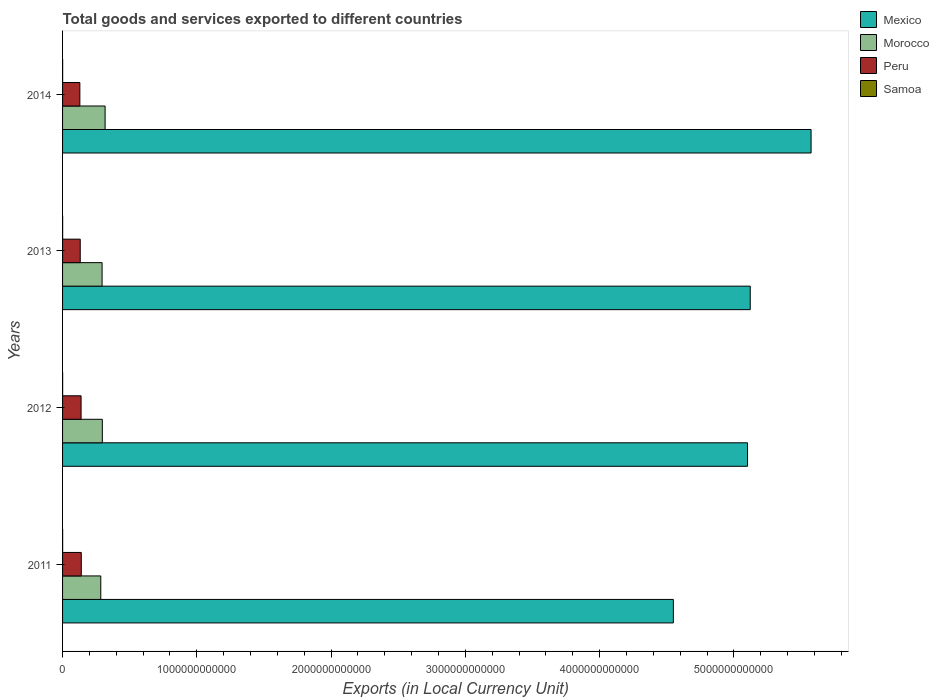How many groups of bars are there?
Give a very brief answer. 4. Are the number of bars per tick equal to the number of legend labels?
Provide a short and direct response. Yes. How many bars are there on the 4th tick from the bottom?
Provide a short and direct response. 4. In how many cases, is the number of bars for a given year not equal to the number of legend labels?
Keep it short and to the point. 0. What is the Amount of goods and services exports in Morocco in 2013?
Give a very brief answer. 2.94e+11. Across all years, what is the maximum Amount of goods and services exports in Peru?
Make the answer very short. 1.39e+11. Across all years, what is the minimum Amount of goods and services exports in Mexico?
Your answer should be compact. 4.55e+12. What is the total Amount of goods and services exports in Morocco in the graph?
Keep it short and to the point. 1.19e+12. What is the difference between the Amount of goods and services exports in Morocco in 2012 and that in 2013?
Provide a succinct answer. 1.84e+09. What is the difference between the Amount of goods and services exports in Mexico in 2011 and the Amount of goods and services exports in Peru in 2014?
Make the answer very short. 4.42e+12. What is the average Amount of goods and services exports in Peru per year?
Provide a succinct answer. 1.34e+11. In the year 2013, what is the difference between the Amount of goods and services exports in Peru and Amount of goods and services exports in Mexico?
Offer a very short reply. -4.99e+12. What is the ratio of the Amount of goods and services exports in Mexico in 2011 to that in 2014?
Provide a short and direct response. 0.82. What is the difference between the highest and the second highest Amount of goods and services exports in Samoa?
Your answer should be very brief. 3.05e+07. What is the difference between the highest and the lowest Amount of goods and services exports in Morocco?
Your answer should be very brief. 3.23e+1. In how many years, is the Amount of goods and services exports in Samoa greater than the average Amount of goods and services exports in Samoa taken over all years?
Make the answer very short. 2. Is the sum of the Amount of goods and services exports in Samoa in 2011 and 2014 greater than the maximum Amount of goods and services exports in Peru across all years?
Make the answer very short. No. What does the 3rd bar from the top in 2014 represents?
Make the answer very short. Morocco. What does the 3rd bar from the bottom in 2011 represents?
Provide a succinct answer. Peru. Are all the bars in the graph horizontal?
Provide a short and direct response. Yes. How many years are there in the graph?
Provide a short and direct response. 4. What is the difference between two consecutive major ticks on the X-axis?
Make the answer very short. 1.00e+12. Are the values on the major ticks of X-axis written in scientific E-notation?
Your answer should be compact. No. Where does the legend appear in the graph?
Offer a terse response. Top right. What is the title of the graph?
Offer a very short reply. Total goods and services exported to different countries. Does "South Sudan" appear as one of the legend labels in the graph?
Offer a very short reply. No. What is the label or title of the X-axis?
Provide a succinct answer. Exports (in Local Currency Unit). What is the Exports (in Local Currency Unit) in Mexico in 2011?
Offer a terse response. 4.55e+12. What is the Exports (in Local Currency Unit) of Morocco in 2011?
Make the answer very short. 2.85e+11. What is the Exports (in Local Currency Unit) of Peru in 2011?
Provide a short and direct response. 1.39e+11. What is the Exports (in Local Currency Unit) of Samoa in 2011?
Give a very brief answer. 5.07e+08. What is the Exports (in Local Currency Unit) of Mexico in 2012?
Provide a succinct answer. 5.10e+12. What is the Exports (in Local Currency Unit) in Morocco in 2012?
Make the answer very short. 2.96e+11. What is the Exports (in Local Currency Unit) of Peru in 2012?
Your answer should be compact. 1.38e+11. What is the Exports (in Local Currency Unit) of Samoa in 2012?
Give a very brief answer. 5.10e+08. What is the Exports (in Local Currency Unit) in Mexico in 2013?
Your answer should be compact. 5.12e+12. What is the Exports (in Local Currency Unit) in Morocco in 2013?
Keep it short and to the point. 2.94e+11. What is the Exports (in Local Currency Unit) of Peru in 2013?
Provide a succinct answer. 1.32e+11. What is the Exports (in Local Currency Unit) of Samoa in 2013?
Make the answer very short. 5.58e+08. What is the Exports (in Local Currency Unit) of Mexico in 2014?
Give a very brief answer. 5.57e+12. What is the Exports (in Local Currency Unit) in Morocco in 2014?
Your answer should be very brief. 3.17e+11. What is the Exports (in Local Currency Unit) of Peru in 2014?
Make the answer very short. 1.29e+11. What is the Exports (in Local Currency Unit) of Samoa in 2014?
Provide a succinct answer. 5.27e+08. Across all years, what is the maximum Exports (in Local Currency Unit) in Mexico?
Your answer should be compact. 5.57e+12. Across all years, what is the maximum Exports (in Local Currency Unit) of Morocco?
Your response must be concise. 3.17e+11. Across all years, what is the maximum Exports (in Local Currency Unit) in Peru?
Your answer should be compact. 1.39e+11. Across all years, what is the maximum Exports (in Local Currency Unit) of Samoa?
Your response must be concise. 5.58e+08. Across all years, what is the minimum Exports (in Local Currency Unit) in Mexico?
Keep it short and to the point. 4.55e+12. Across all years, what is the minimum Exports (in Local Currency Unit) of Morocco?
Give a very brief answer. 2.85e+11. Across all years, what is the minimum Exports (in Local Currency Unit) of Peru?
Your answer should be very brief. 1.29e+11. Across all years, what is the minimum Exports (in Local Currency Unit) of Samoa?
Give a very brief answer. 5.07e+08. What is the total Exports (in Local Currency Unit) in Mexico in the graph?
Your answer should be compact. 2.03e+13. What is the total Exports (in Local Currency Unit) of Morocco in the graph?
Your answer should be compact. 1.19e+12. What is the total Exports (in Local Currency Unit) of Peru in the graph?
Provide a succinct answer. 5.38e+11. What is the total Exports (in Local Currency Unit) of Samoa in the graph?
Give a very brief answer. 2.10e+09. What is the difference between the Exports (in Local Currency Unit) of Mexico in 2011 and that in 2012?
Your answer should be very brief. -5.52e+11. What is the difference between the Exports (in Local Currency Unit) of Morocco in 2011 and that in 2012?
Make the answer very short. -1.16e+1. What is the difference between the Exports (in Local Currency Unit) in Peru in 2011 and that in 2012?
Give a very brief answer. 1.42e+09. What is the difference between the Exports (in Local Currency Unit) of Samoa in 2011 and that in 2012?
Offer a terse response. -3.29e+06. What is the difference between the Exports (in Local Currency Unit) in Mexico in 2011 and that in 2013?
Offer a very short reply. -5.73e+11. What is the difference between the Exports (in Local Currency Unit) of Morocco in 2011 and that in 2013?
Offer a terse response. -9.75e+09. What is the difference between the Exports (in Local Currency Unit) in Peru in 2011 and that in 2013?
Your response must be concise. 7.71e+09. What is the difference between the Exports (in Local Currency Unit) of Samoa in 2011 and that in 2013?
Your answer should be very brief. -5.06e+07. What is the difference between the Exports (in Local Currency Unit) of Mexico in 2011 and that in 2014?
Offer a very short reply. -1.03e+12. What is the difference between the Exports (in Local Currency Unit) of Morocco in 2011 and that in 2014?
Your answer should be compact. -3.23e+1. What is the difference between the Exports (in Local Currency Unit) in Peru in 2011 and that in 2014?
Ensure brevity in your answer.  1.05e+1. What is the difference between the Exports (in Local Currency Unit) of Samoa in 2011 and that in 2014?
Keep it short and to the point. -2.02e+07. What is the difference between the Exports (in Local Currency Unit) in Mexico in 2012 and that in 2013?
Offer a very short reply. -2.02e+1. What is the difference between the Exports (in Local Currency Unit) in Morocco in 2012 and that in 2013?
Make the answer very short. 1.84e+09. What is the difference between the Exports (in Local Currency Unit) of Peru in 2012 and that in 2013?
Ensure brevity in your answer.  6.30e+09. What is the difference between the Exports (in Local Currency Unit) in Samoa in 2012 and that in 2013?
Make the answer very short. -4.74e+07. What is the difference between the Exports (in Local Currency Unit) of Mexico in 2012 and that in 2014?
Your answer should be very brief. -4.73e+11. What is the difference between the Exports (in Local Currency Unit) of Morocco in 2012 and that in 2014?
Offer a very short reply. -2.07e+1. What is the difference between the Exports (in Local Currency Unit) of Peru in 2012 and that in 2014?
Your answer should be compact. 9.07e+09. What is the difference between the Exports (in Local Currency Unit) of Samoa in 2012 and that in 2014?
Your answer should be compact. -1.69e+07. What is the difference between the Exports (in Local Currency Unit) of Mexico in 2013 and that in 2014?
Ensure brevity in your answer.  -4.53e+11. What is the difference between the Exports (in Local Currency Unit) of Morocco in 2013 and that in 2014?
Provide a succinct answer. -2.25e+1. What is the difference between the Exports (in Local Currency Unit) in Peru in 2013 and that in 2014?
Ensure brevity in your answer.  2.78e+09. What is the difference between the Exports (in Local Currency Unit) of Samoa in 2013 and that in 2014?
Keep it short and to the point. 3.05e+07. What is the difference between the Exports (in Local Currency Unit) in Mexico in 2011 and the Exports (in Local Currency Unit) in Morocco in 2012?
Provide a short and direct response. 4.25e+12. What is the difference between the Exports (in Local Currency Unit) in Mexico in 2011 and the Exports (in Local Currency Unit) in Peru in 2012?
Offer a terse response. 4.41e+12. What is the difference between the Exports (in Local Currency Unit) in Mexico in 2011 and the Exports (in Local Currency Unit) in Samoa in 2012?
Your response must be concise. 4.55e+12. What is the difference between the Exports (in Local Currency Unit) of Morocco in 2011 and the Exports (in Local Currency Unit) of Peru in 2012?
Ensure brevity in your answer.  1.47e+11. What is the difference between the Exports (in Local Currency Unit) of Morocco in 2011 and the Exports (in Local Currency Unit) of Samoa in 2012?
Keep it short and to the point. 2.84e+11. What is the difference between the Exports (in Local Currency Unit) of Peru in 2011 and the Exports (in Local Currency Unit) of Samoa in 2012?
Keep it short and to the point. 1.39e+11. What is the difference between the Exports (in Local Currency Unit) in Mexico in 2011 and the Exports (in Local Currency Unit) in Morocco in 2013?
Your answer should be very brief. 4.25e+12. What is the difference between the Exports (in Local Currency Unit) in Mexico in 2011 and the Exports (in Local Currency Unit) in Peru in 2013?
Provide a short and direct response. 4.42e+12. What is the difference between the Exports (in Local Currency Unit) of Mexico in 2011 and the Exports (in Local Currency Unit) of Samoa in 2013?
Keep it short and to the point. 4.55e+12. What is the difference between the Exports (in Local Currency Unit) of Morocco in 2011 and the Exports (in Local Currency Unit) of Peru in 2013?
Your answer should be compact. 1.53e+11. What is the difference between the Exports (in Local Currency Unit) in Morocco in 2011 and the Exports (in Local Currency Unit) in Samoa in 2013?
Offer a terse response. 2.84e+11. What is the difference between the Exports (in Local Currency Unit) of Peru in 2011 and the Exports (in Local Currency Unit) of Samoa in 2013?
Your response must be concise. 1.39e+11. What is the difference between the Exports (in Local Currency Unit) in Mexico in 2011 and the Exports (in Local Currency Unit) in Morocco in 2014?
Offer a very short reply. 4.23e+12. What is the difference between the Exports (in Local Currency Unit) in Mexico in 2011 and the Exports (in Local Currency Unit) in Peru in 2014?
Your answer should be compact. 4.42e+12. What is the difference between the Exports (in Local Currency Unit) of Mexico in 2011 and the Exports (in Local Currency Unit) of Samoa in 2014?
Your answer should be compact. 4.55e+12. What is the difference between the Exports (in Local Currency Unit) of Morocco in 2011 and the Exports (in Local Currency Unit) of Peru in 2014?
Offer a terse response. 1.56e+11. What is the difference between the Exports (in Local Currency Unit) in Morocco in 2011 and the Exports (in Local Currency Unit) in Samoa in 2014?
Offer a very short reply. 2.84e+11. What is the difference between the Exports (in Local Currency Unit) of Peru in 2011 and the Exports (in Local Currency Unit) of Samoa in 2014?
Your answer should be compact. 1.39e+11. What is the difference between the Exports (in Local Currency Unit) of Mexico in 2012 and the Exports (in Local Currency Unit) of Morocco in 2013?
Give a very brief answer. 4.81e+12. What is the difference between the Exports (in Local Currency Unit) of Mexico in 2012 and the Exports (in Local Currency Unit) of Peru in 2013?
Offer a terse response. 4.97e+12. What is the difference between the Exports (in Local Currency Unit) of Mexico in 2012 and the Exports (in Local Currency Unit) of Samoa in 2013?
Give a very brief answer. 5.10e+12. What is the difference between the Exports (in Local Currency Unit) in Morocco in 2012 and the Exports (in Local Currency Unit) in Peru in 2013?
Keep it short and to the point. 1.65e+11. What is the difference between the Exports (in Local Currency Unit) of Morocco in 2012 and the Exports (in Local Currency Unit) of Samoa in 2013?
Your answer should be compact. 2.96e+11. What is the difference between the Exports (in Local Currency Unit) in Peru in 2012 and the Exports (in Local Currency Unit) in Samoa in 2013?
Your answer should be very brief. 1.37e+11. What is the difference between the Exports (in Local Currency Unit) of Mexico in 2012 and the Exports (in Local Currency Unit) of Morocco in 2014?
Keep it short and to the point. 4.78e+12. What is the difference between the Exports (in Local Currency Unit) in Mexico in 2012 and the Exports (in Local Currency Unit) in Peru in 2014?
Ensure brevity in your answer.  4.97e+12. What is the difference between the Exports (in Local Currency Unit) of Mexico in 2012 and the Exports (in Local Currency Unit) of Samoa in 2014?
Keep it short and to the point. 5.10e+12. What is the difference between the Exports (in Local Currency Unit) in Morocco in 2012 and the Exports (in Local Currency Unit) in Peru in 2014?
Your response must be concise. 1.67e+11. What is the difference between the Exports (in Local Currency Unit) in Morocco in 2012 and the Exports (in Local Currency Unit) in Samoa in 2014?
Make the answer very short. 2.96e+11. What is the difference between the Exports (in Local Currency Unit) of Peru in 2012 and the Exports (in Local Currency Unit) of Samoa in 2014?
Your answer should be very brief. 1.37e+11. What is the difference between the Exports (in Local Currency Unit) of Mexico in 2013 and the Exports (in Local Currency Unit) of Morocco in 2014?
Make the answer very short. 4.80e+12. What is the difference between the Exports (in Local Currency Unit) of Mexico in 2013 and the Exports (in Local Currency Unit) of Peru in 2014?
Give a very brief answer. 4.99e+12. What is the difference between the Exports (in Local Currency Unit) of Mexico in 2013 and the Exports (in Local Currency Unit) of Samoa in 2014?
Provide a short and direct response. 5.12e+12. What is the difference between the Exports (in Local Currency Unit) of Morocco in 2013 and the Exports (in Local Currency Unit) of Peru in 2014?
Offer a terse response. 1.65e+11. What is the difference between the Exports (in Local Currency Unit) in Morocco in 2013 and the Exports (in Local Currency Unit) in Samoa in 2014?
Make the answer very short. 2.94e+11. What is the difference between the Exports (in Local Currency Unit) in Peru in 2013 and the Exports (in Local Currency Unit) in Samoa in 2014?
Keep it short and to the point. 1.31e+11. What is the average Exports (in Local Currency Unit) in Mexico per year?
Your answer should be compact. 5.09e+12. What is the average Exports (in Local Currency Unit) in Morocco per year?
Provide a short and direct response. 2.98e+11. What is the average Exports (in Local Currency Unit) of Peru per year?
Provide a succinct answer. 1.34e+11. What is the average Exports (in Local Currency Unit) of Samoa per year?
Your response must be concise. 5.25e+08. In the year 2011, what is the difference between the Exports (in Local Currency Unit) in Mexico and Exports (in Local Currency Unit) in Morocco?
Your response must be concise. 4.26e+12. In the year 2011, what is the difference between the Exports (in Local Currency Unit) of Mexico and Exports (in Local Currency Unit) of Peru?
Give a very brief answer. 4.41e+12. In the year 2011, what is the difference between the Exports (in Local Currency Unit) in Mexico and Exports (in Local Currency Unit) in Samoa?
Offer a terse response. 4.55e+12. In the year 2011, what is the difference between the Exports (in Local Currency Unit) of Morocco and Exports (in Local Currency Unit) of Peru?
Your answer should be very brief. 1.45e+11. In the year 2011, what is the difference between the Exports (in Local Currency Unit) of Morocco and Exports (in Local Currency Unit) of Samoa?
Give a very brief answer. 2.84e+11. In the year 2011, what is the difference between the Exports (in Local Currency Unit) of Peru and Exports (in Local Currency Unit) of Samoa?
Offer a terse response. 1.39e+11. In the year 2012, what is the difference between the Exports (in Local Currency Unit) of Mexico and Exports (in Local Currency Unit) of Morocco?
Your response must be concise. 4.81e+12. In the year 2012, what is the difference between the Exports (in Local Currency Unit) of Mexico and Exports (in Local Currency Unit) of Peru?
Provide a short and direct response. 4.96e+12. In the year 2012, what is the difference between the Exports (in Local Currency Unit) of Mexico and Exports (in Local Currency Unit) of Samoa?
Provide a succinct answer. 5.10e+12. In the year 2012, what is the difference between the Exports (in Local Currency Unit) of Morocco and Exports (in Local Currency Unit) of Peru?
Keep it short and to the point. 1.58e+11. In the year 2012, what is the difference between the Exports (in Local Currency Unit) of Morocco and Exports (in Local Currency Unit) of Samoa?
Keep it short and to the point. 2.96e+11. In the year 2012, what is the difference between the Exports (in Local Currency Unit) of Peru and Exports (in Local Currency Unit) of Samoa?
Give a very brief answer. 1.37e+11. In the year 2013, what is the difference between the Exports (in Local Currency Unit) in Mexico and Exports (in Local Currency Unit) in Morocco?
Make the answer very short. 4.83e+12. In the year 2013, what is the difference between the Exports (in Local Currency Unit) of Mexico and Exports (in Local Currency Unit) of Peru?
Give a very brief answer. 4.99e+12. In the year 2013, what is the difference between the Exports (in Local Currency Unit) of Mexico and Exports (in Local Currency Unit) of Samoa?
Provide a short and direct response. 5.12e+12. In the year 2013, what is the difference between the Exports (in Local Currency Unit) of Morocco and Exports (in Local Currency Unit) of Peru?
Offer a very short reply. 1.63e+11. In the year 2013, what is the difference between the Exports (in Local Currency Unit) in Morocco and Exports (in Local Currency Unit) in Samoa?
Provide a short and direct response. 2.94e+11. In the year 2013, what is the difference between the Exports (in Local Currency Unit) in Peru and Exports (in Local Currency Unit) in Samoa?
Your answer should be compact. 1.31e+11. In the year 2014, what is the difference between the Exports (in Local Currency Unit) in Mexico and Exports (in Local Currency Unit) in Morocco?
Make the answer very short. 5.26e+12. In the year 2014, what is the difference between the Exports (in Local Currency Unit) in Mexico and Exports (in Local Currency Unit) in Peru?
Offer a terse response. 5.45e+12. In the year 2014, what is the difference between the Exports (in Local Currency Unit) of Mexico and Exports (in Local Currency Unit) of Samoa?
Offer a very short reply. 5.57e+12. In the year 2014, what is the difference between the Exports (in Local Currency Unit) of Morocco and Exports (in Local Currency Unit) of Peru?
Offer a very short reply. 1.88e+11. In the year 2014, what is the difference between the Exports (in Local Currency Unit) in Morocco and Exports (in Local Currency Unit) in Samoa?
Make the answer very short. 3.16e+11. In the year 2014, what is the difference between the Exports (in Local Currency Unit) in Peru and Exports (in Local Currency Unit) in Samoa?
Offer a terse response. 1.28e+11. What is the ratio of the Exports (in Local Currency Unit) in Mexico in 2011 to that in 2012?
Offer a terse response. 0.89. What is the ratio of the Exports (in Local Currency Unit) of Morocco in 2011 to that in 2012?
Your answer should be compact. 0.96. What is the ratio of the Exports (in Local Currency Unit) of Peru in 2011 to that in 2012?
Make the answer very short. 1.01. What is the ratio of the Exports (in Local Currency Unit) of Samoa in 2011 to that in 2012?
Keep it short and to the point. 0.99. What is the ratio of the Exports (in Local Currency Unit) of Mexico in 2011 to that in 2013?
Offer a very short reply. 0.89. What is the ratio of the Exports (in Local Currency Unit) in Morocco in 2011 to that in 2013?
Keep it short and to the point. 0.97. What is the ratio of the Exports (in Local Currency Unit) in Peru in 2011 to that in 2013?
Your answer should be compact. 1.06. What is the ratio of the Exports (in Local Currency Unit) of Samoa in 2011 to that in 2013?
Your answer should be very brief. 0.91. What is the ratio of the Exports (in Local Currency Unit) in Mexico in 2011 to that in 2014?
Ensure brevity in your answer.  0.82. What is the ratio of the Exports (in Local Currency Unit) of Morocco in 2011 to that in 2014?
Your answer should be compact. 0.9. What is the ratio of the Exports (in Local Currency Unit) in Peru in 2011 to that in 2014?
Offer a terse response. 1.08. What is the ratio of the Exports (in Local Currency Unit) of Samoa in 2011 to that in 2014?
Your answer should be compact. 0.96. What is the ratio of the Exports (in Local Currency Unit) of Morocco in 2012 to that in 2013?
Keep it short and to the point. 1.01. What is the ratio of the Exports (in Local Currency Unit) in Peru in 2012 to that in 2013?
Keep it short and to the point. 1.05. What is the ratio of the Exports (in Local Currency Unit) in Samoa in 2012 to that in 2013?
Your answer should be very brief. 0.92. What is the ratio of the Exports (in Local Currency Unit) in Mexico in 2012 to that in 2014?
Ensure brevity in your answer.  0.92. What is the ratio of the Exports (in Local Currency Unit) of Morocco in 2012 to that in 2014?
Ensure brevity in your answer.  0.93. What is the ratio of the Exports (in Local Currency Unit) of Peru in 2012 to that in 2014?
Give a very brief answer. 1.07. What is the ratio of the Exports (in Local Currency Unit) of Mexico in 2013 to that in 2014?
Your response must be concise. 0.92. What is the ratio of the Exports (in Local Currency Unit) of Morocco in 2013 to that in 2014?
Provide a succinct answer. 0.93. What is the ratio of the Exports (in Local Currency Unit) of Peru in 2013 to that in 2014?
Provide a short and direct response. 1.02. What is the ratio of the Exports (in Local Currency Unit) in Samoa in 2013 to that in 2014?
Offer a terse response. 1.06. What is the difference between the highest and the second highest Exports (in Local Currency Unit) of Mexico?
Your answer should be very brief. 4.53e+11. What is the difference between the highest and the second highest Exports (in Local Currency Unit) of Morocco?
Your response must be concise. 2.07e+1. What is the difference between the highest and the second highest Exports (in Local Currency Unit) in Peru?
Your answer should be very brief. 1.42e+09. What is the difference between the highest and the second highest Exports (in Local Currency Unit) in Samoa?
Provide a succinct answer. 3.05e+07. What is the difference between the highest and the lowest Exports (in Local Currency Unit) in Mexico?
Offer a terse response. 1.03e+12. What is the difference between the highest and the lowest Exports (in Local Currency Unit) of Morocco?
Your response must be concise. 3.23e+1. What is the difference between the highest and the lowest Exports (in Local Currency Unit) of Peru?
Offer a terse response. 1.05e+1. What is the difference between the highest and the lowest Exports (in Local Currency Unit) of Samoa?
Provide a short and direct response. 5.06e+07. 